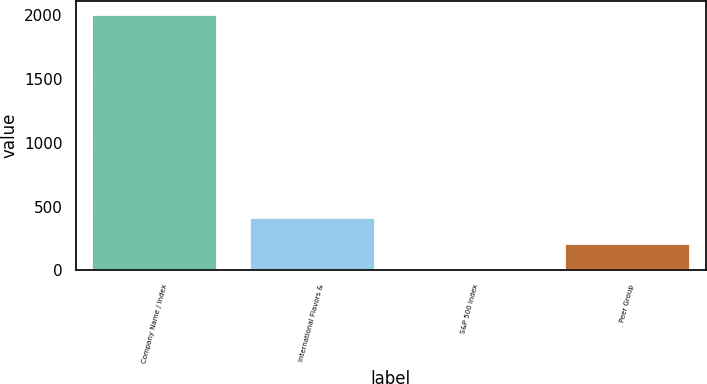Convert chart to OTSL. <chart><loc_0><loc_0><loc_500><loc_500><bar_chart><fcel>Company Name / Index<fcel>International Flavors &<fcel>S&P 500 Index<fcel>Peer Group<nl><fcel>2010<fcel>414.04<fcel>15.06<fcel>214.55<nl></chart> 